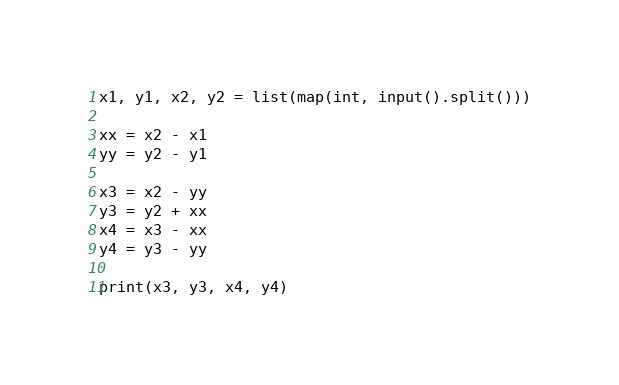Convert code to text. <code><loc_0><loc_0><loc_500><loc_500><_Python_>x1, y1, x2, y2 = list(map(int, input().split()))

xx = x2 - x1
yy = y2 - y1

x3 = x2 - yy
y3 = y2 + xx
x4 = x3 - xx
y4 = y3 - yy

print(x3, y3, x4, y4)</code> 